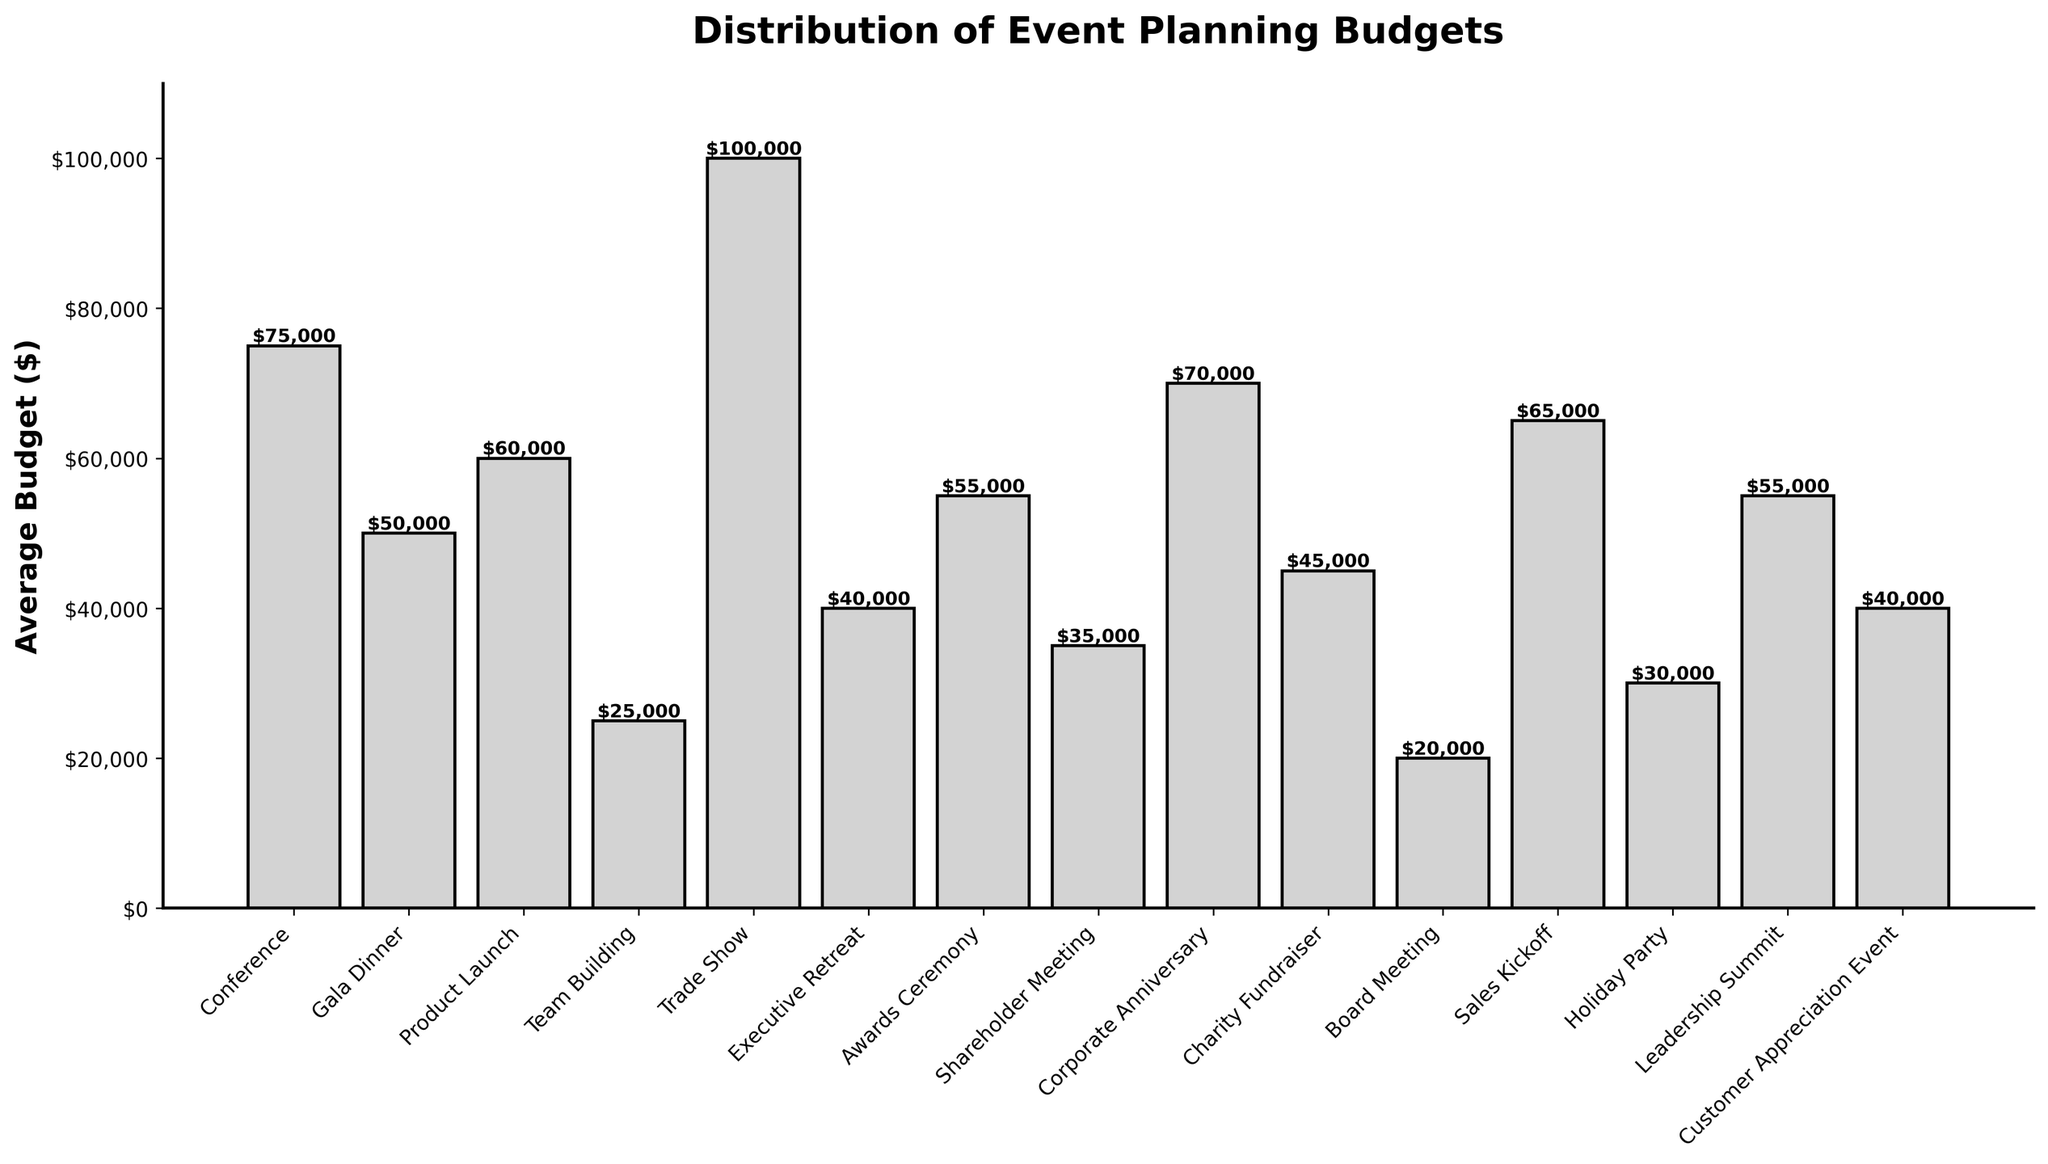What event type has the highest average budget? The bar chart shows various event types and their corresponding average budgets. The tallest bar represents the highest budget. Here, the Trade Show has the highest average budget at $100,000.
Answer: Trade Show What is the total average budget for Conferences, Product Launches, and Corporate Anniversaries? To find the total, sum the average budgets of all three event types. Conference ($75,000) + Product Launch ($60,000) + Corporate Anniversary ($70,000) = $205,000.
Answer: $205,000 Which event type has a lower average budget: Gala Dinners or Awards Ceremonies? Compare the heights of the bars representing Gala Dinners and Awards Ceremonies. Gala Dinners have an average budget of $50,000, and Awards Ceremonies have $55,000. So, Gala Dinners have a lower average budget.
Answer: Gala Dinners What is the difference in average budgets between Trade Shows and Board Meetings? Subtract the Board Meetings' average budget ($20,000) from the Trade Shows' average budget ($100,000). The difference is $80,000.
Answer: $80,000 What is the average budget of the three least expensive event types? Identify the three shortest bars: Board Meeting ($20,000), Team Building ($25,000), and Holiday Party ($30,000). The average budget is calculated as (20,000 + 25,000 + 30,000) / 3 = $25,000.
Answer: $25,000 How many event types have an average budget of $50,000 or more? Count the bars with a height representing $50,000 or more. They are: Conference, Gala Dinner, Product Launch, Trade Show, Awards Ceremony, Corporate Anniversary, Sales Kickoff, and Leadership Summit, totaling 8 event types.
Answer: 8 What is the average budget for Customer Appreciation Events? Is it more or less than Executive Retreats? The average budget for Customer Appreciation Events is $40,000, and for Executive Retreats, it is also $40,000. Therefore, their budgets are equal.
Answer: Equal Which event type has a budget close to the average budget for Corporate Anniversaries but somewhat lower? Check for event types with budgets close to $70,000 but slightly lower. The Sales Kickoff has an average budget of $65,000, which is close but lower.
Answer: Sales Kickoff What is the combined average budget of the most and least expensive event types? The most expensive is Trade Show ($100,000) and the least expensive is Board Meeting ($20,000). Their combined average budget is $100,000 + $20,000 = $120,000.
Answer: $120,000 